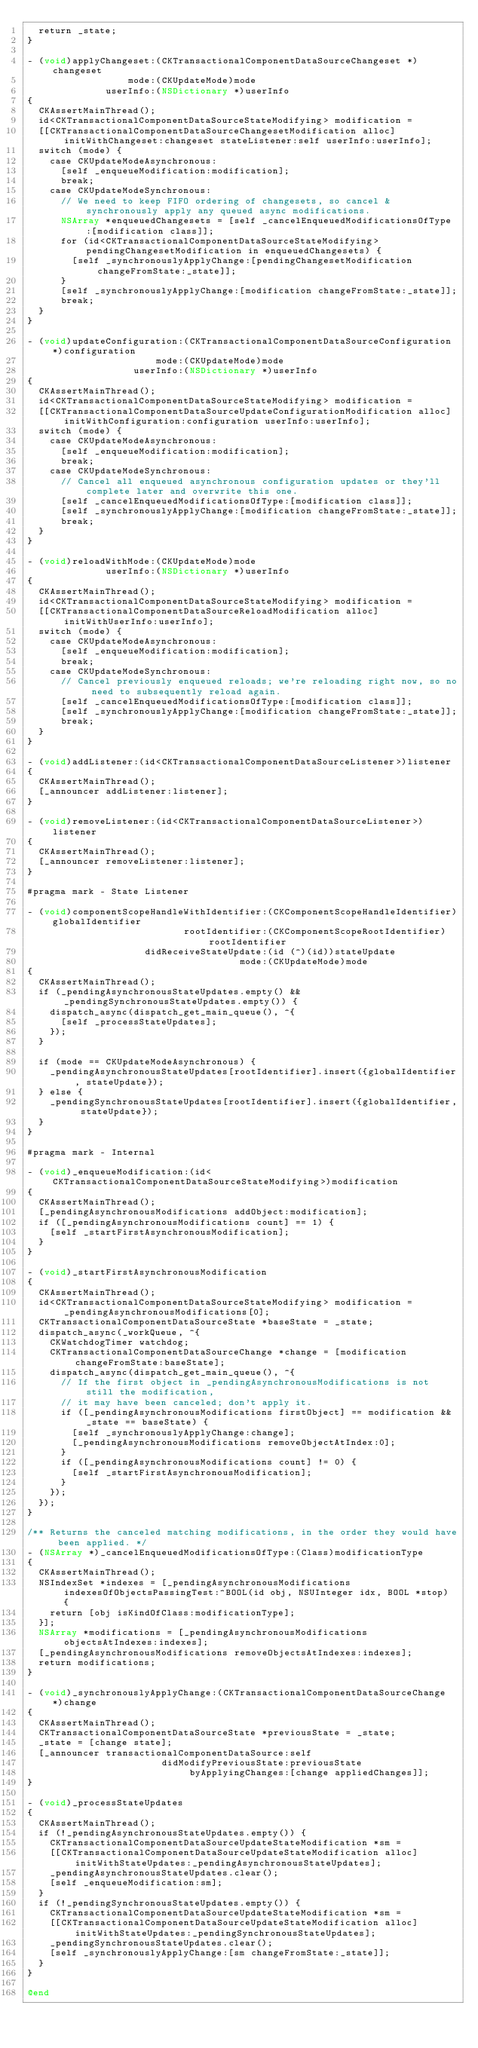Convert code to text. <code><loc_0><loc_0><loc_500><loc_500><_ObjectiveC_>  return _state;
}

- (void)applyChangeset:(CKTransactionalComponentDataSourceChangeset *)changeset
                  mode:(CKUpdateMode)mode
              userInfo:(NSDictionary *)userInfo
{
  CKAssertMainThread();
  id<CKTransactionalComponentDataSourceStateModifying> modification =
  [[CKTransactionalComponentDataSourceChangesetModification alloc] initWithChangeset:changeset stateListener:self userInfo:userInfo];
  switch (mode) {
    case CKUpdateModeAsynchronous:
      [self _enqueueModification:modification];
      break;
    case CKUpdateModeSynchronous:
      // We need to keep FIFO ordering of changesets, so cancel & synchronously apply any queued async modifications.
      NSArray *enqueuedChangesets = [self _cancelEnqueuedModificationsOfType:[modification class]];
      for (id<CKTransactionalComponentDataSourceStateModifying> pendingChangesetModification in enqueuedChangesets) {
        [self _synchronouslyApplyChange:[pendingChangesetModification changeFromState:_state]];
      }
      [self _synchronouslyApplyChange:[modification changeFromState:_state]];
      break;
  }
}

- (void)updateConfiguration:(CKTransactionalComponentDataSourceConfiguration *)configuration
                       mode:(CKUpdateMode)mode
                   userInfo:(NSDictionary *)userInfo
{
  CKAssertMainThread();
  id<CKTransactionalComponentDataSourceStateModifying> modification =
  [[CKTransactionalComponentDataSourceUpdateConfigurationModification alloc] initWithConfiguration:configuration userInfo:userInfo];
  switch (mode) {
    case CKUpdateModeAsynchronous:
      [self _enqueueModification:modification];
      break;
    case CKUpdateModeSynchronous:
      // Cancel all enqueued asynchronous configuration updates or they'll complete later and overwrite this one.
      [self _cancelEnqueuedModificationsOfType:[modification class]];
      [self _synchronouslyApplyChange:[modification changeFromState:_state]];
      break;
  }
}

- (void)reloadWithMode:(CKUpdateMode)mode
              userInfo:(NSDictionary *)userInfo
{
  CKAssertMainThread();
  id<CKTransactionalComponentDataSourceStateModifying> modification =
  [[CKTransactionalComponentDataSourceReloadModification alloc] initWithUserInfo:userInfo];
  switch (mode) {
    case CKUpdateModeAsynchronous:
      [self _enqueueModification:modification];
      break;
    case CKUpdateModeSynchronous:
      // Cancel previously enqueued reloads; we're reloading right now, so no need to subsequently reload again.
      [self _cancelEnqueuedModificationsOfType:[modification class]];
      [self _synchronouslyApplyChange:[modification changeFromState:_state]];
      break;
  }
}

- (void)addListener:(id<CKTransactionalComponentDataSourceListener>)listener
{
  CKAssertMainThread();
  [_announcer addListener:listener];
}

- (void)removeListener:(id<CKTransactionalComponentDataSourceListener>)listener
{
  CKAssertMainThread();
  [_announcer removeListener:listener];
}

#pragma mark - State Listener

- (void)componentScopeHandleWithIdentifier:(CKComponentScopeHandleIdentifier)globalIdentifier
                            rootIdentifier:(CKComponentScopeRootIdentifier)rootIdentifier
                     didReceiveStateUpdate:(id (^)(id))stateUpdate
                                      mode:(CKUpdateMode)mode
{
  CKAssertMainThread();
  if (_pendingAsynchronousStateUpdates.empty() && _pendingSynchronousStateUpdates.empty()) {
    dispatch_async(dispatch_get_main_queue(), ^{
      [self _processStateUpdates];
    });
  }

  if (mode == CKUpdateModeAsynchronous) {
    _pendingAsynchronousStateUpdates[rootIdentifier].insert({globalIdentifier, stateUpdate});
  } else {
    _pendingSynchronousStateUpdates[rootIdentifier].insert({globalIdentifier, stateUpdate});
  }
}

#pragma mark - Internal

- (void)_enqueueModification:(id<CKTransactionalComponentDataSourceStateModifying>)modification
{
  CKAssertMainThread();
  [_pendingAsynchronousModifications addObject:modification];
  if ([_pendingAsynchronousModifications count] == 1) {
    [self _startFirstAsynchronousModification];
  }
}

- (void)_startFirstAsynchronousModification
{
  CKAssertMainThread();
  id<CKTransactionalComponentDataSourceStateModifying> modification = _pendingAsynchronousModifications[0];
  CKTransactionalComponentDataSourceState *baseState = _state;
  dispatch_async(_workQueue, ^{
    CKWatchdogTimer watchdog;
    CKTransactionalComponentDataSourceChange *change = [modification changeFromState:baseState];
    dispatch_async(dispatch_get_main_queue(), ^{
      // If the first object in _pendingAsynchronousModifications is not still the modification,
      // it may have been canceled; don't apply it.
      if ([_pendingAsynchronousModifications firstObject] == modification && _state == baseState) {
        [self _synchronouslyApplyChange:change];
        [_pendingAsynchronousModifications removeObjectAtIndex:0];
      }
      if ([_pendingAsynchronousModifications count] != 0) {
        [self _startFirstAsynchronousModification];
      }
    });
  });
}

/** Returns the canceled matching modifications, in the order they would have been applied. */
- (NSArray *)_cancelEnqueuedModificationsOfType:(Class)modificationType
{
  CKAssertMainThread();
  NSIndexSet *indexes = [_pendingAsynchronousModifications indexesOfObjectsPassingTest:^BOOL(id obj, NSUInteger idx, BOOL *stop) {
    return [obj isKindOfClass:modificationType];
  }];
  NSArray *modifications = [_pendingAsynchronousModifications objectsAtIndexes:indexes];
  [_pendingAsynchronousModifications removeObjectsAtIndexes:indexes];
  return modifications;
}

- (void)_synchronouslyApplyChange:(CKTransactionalComponentDataSourceChange *)change
{
  CKAssertMainThread();
  CKTransactionalComponentDataSourceState *previousState = _state;
  _state = [change state];
  [_announcer transactionalComponentDataSource:self
                        didModifyPreviousState:previousState
                             byApplyingChanges:[change appliedChanges]];
}

- (void)_processStateUpdates
{
  CKAssertMainThread();
  if (!_pendingAsynchronousStateUpdates.empty()) {
    CKTransactionalComponentDataSourceUpdateStateModification *sm =
    [[CKTransactionalComponentDataSourceUpdateStateModification alloc] initWithStateUpdates:_pendingAsynchronousStateUpdates];
    _pendingAsynchronousStateUpdates.clear();
    [self _enqueueModification:sm];
  }
  if (!_pendingSynchronousStateUpdates.empty()) {
    CKTransactionalComponentDataSourceUpdateStateModification *sm =
    [[CKTransactionalComponentDataSourceUpdateStateModification alloc] initWithStateUpdates:_pendingSynchronousStateUpdates];
    _pendingSynchronousStateUpdates.clear();
    [self _synchronouslyApplyChange:[sm changeFromState:_state]];
  }
}

@end
</code> 